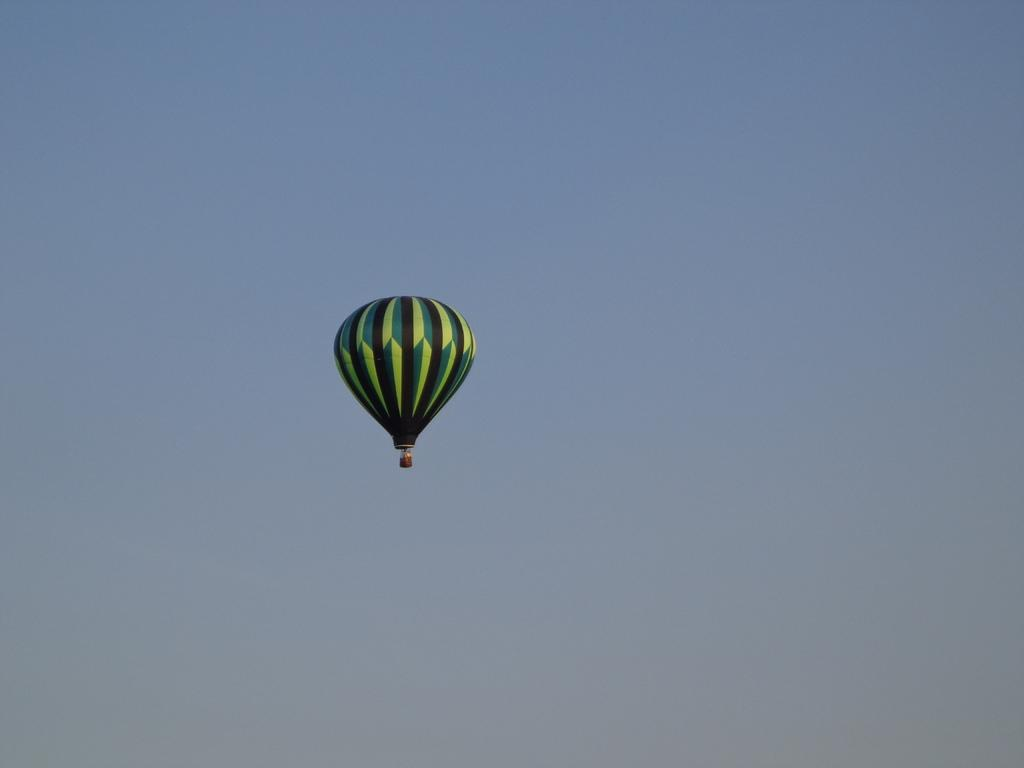Where was the image taken? The image was taken outdoors. What can be seen in the background of the image? There is a sky visible in the background of the image. What is flying in the sky in the image? There is a parachute flying in the sky. What type of patch is sewn onto the parachute in the image? There is no patch visible on the parachute in the image. What connection does the parachute have to the ground in the image? The parachute is flying in the sky, so it is not connected to the ground in the image. 